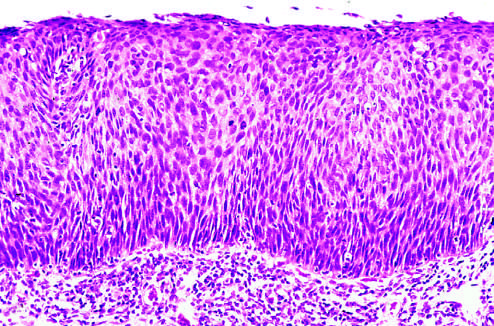what is orderly differentiation of squamous cells?
Answer the question using a single word or phrase. No 